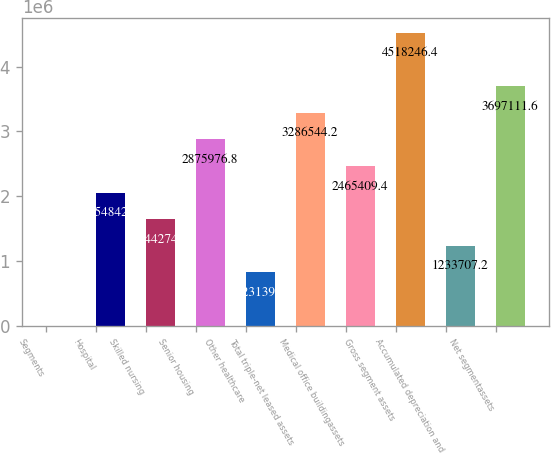Convert chart to OTSL. <chart><loc_0><loc_0><loc_500><loc_500><bar_chart><fcel>Segments<fcel>Hospital<fcel>Skilled nursing<fcel>Senior housing<fcel>Other healthcare<fcel>Total triple-net leased assets<fcel>Medical office buildingassets<fcel>Gross segment assets<fcel>Accumulated depreciation and<fcel>Net segmentassets<nl><fcel>2005<fcel>2.05484e+06<fcel>1.64427e+06<fcel>2.87598e+06<fcel>823140<fcel>3.28654e+06<fcel>2.46541e+06<fcel>4.51825e+06<fcel>1.23371e+06<fcel>3.69711e+06<nl></chart> 